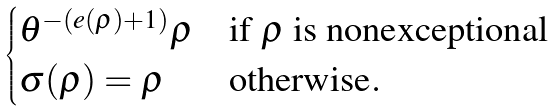<formula> <loc_0><loc_0><loc_500><loc_500>\begin{cases} \theta ^ { - ( e ( \rho ) + 1 ) } \rho & \text {if $\rho$ is nonexceptional} \\ \sigma ( \rho ) = \rho & \text {otherwise} . \end{cases}</formula> 